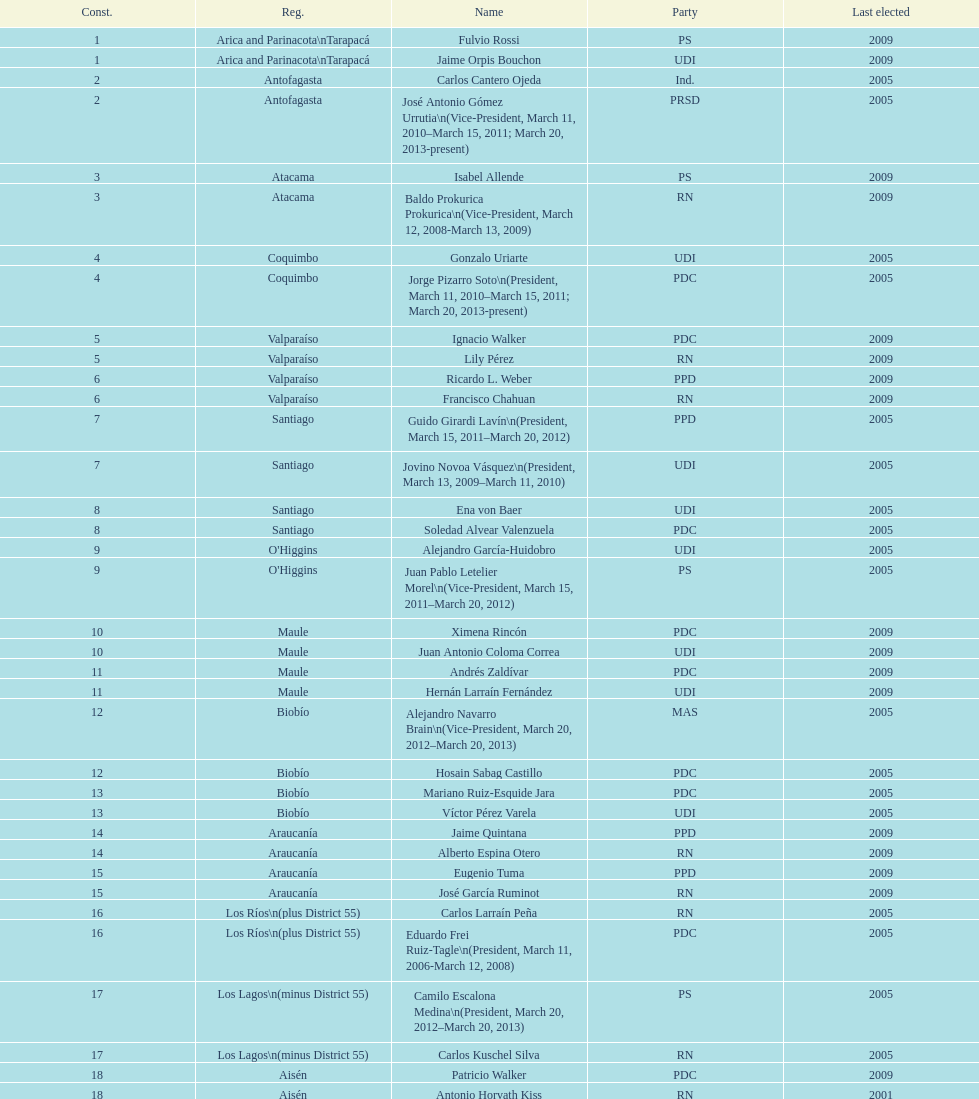Which region is listed below atacama? Coquimbo. 